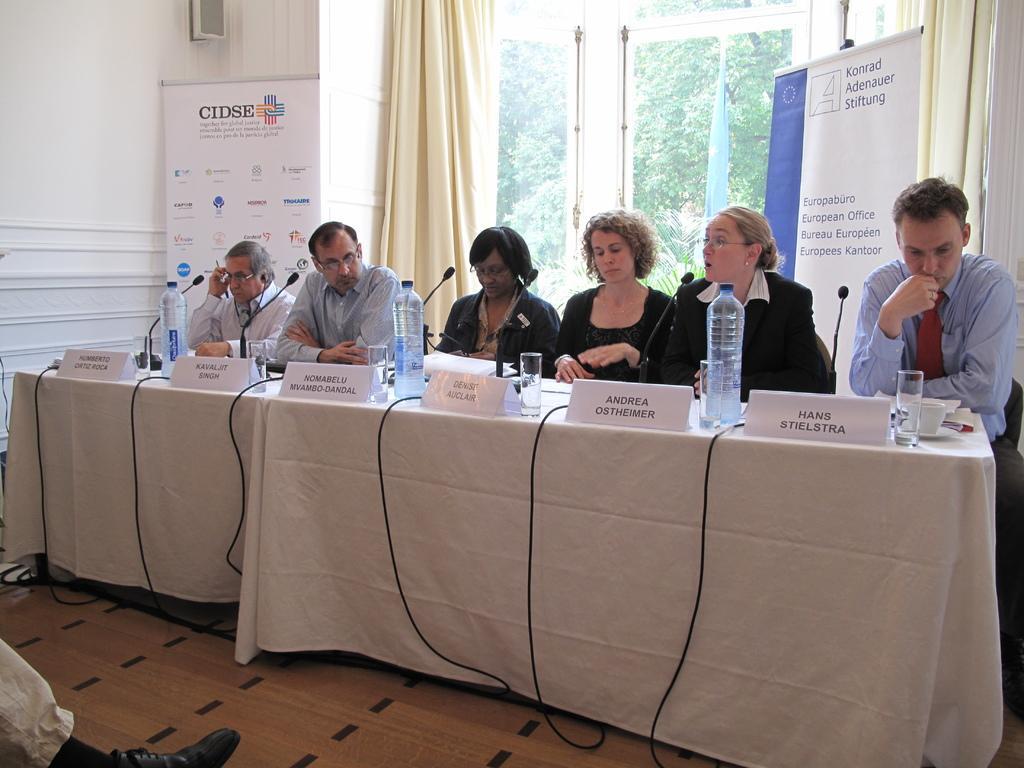Can you describe this image briefly? These persons are sitting on chairs. In-front of them there is a table, on this table there is a cloth, glasses, bottles and mic. Backside of this person's there are banners and window with curtain. From this window we can able to see trees. 